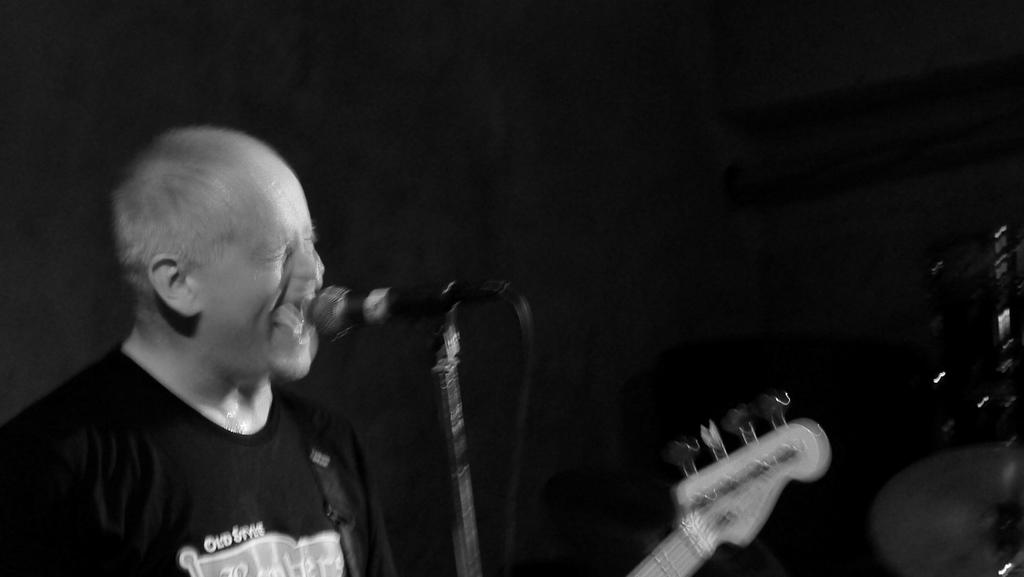Who is present in the image? There is a man in the picture. What object is visible in the image that is typically used for amplifying sound? There is a microphone in the picture. What musical instrument can be seen in the image? There is a guitar in the picture. What color scheme is used in the image? The picture is black and white in color. How many loaves of bread are visible in the image? There are no loaves of bread present in the image. What type of snakes can be seen slithering in the background of the image? There are no snakes visible in the image; it features a man, a microphone, and a guitar in a black and white setting. 